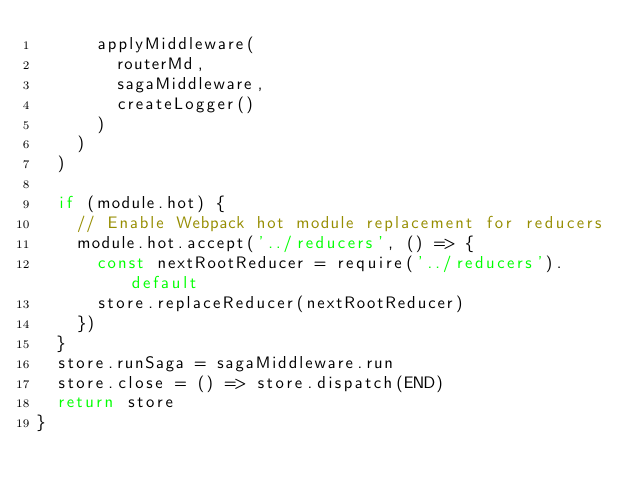<code> <loc_0><loc_0><loc_500><loc_500><_JavaScript_>      applyMiddleware(
        routerMd,
        sagaMiddleware,
        createLogger()
      )
    )
  )

  if (module.hot) {
    // Enable Webpack hot module replacement for reducers
    module.hot.accept('../reducers', () => {
      const nextRootReducer = require('../reducers').default
      store.replaceReducer(nextRootReducer)
    })
  }
  store.runSaga = sagaMiddleware.run
  store.close = () => store.dispatch(END)
  return store
}
</code> 